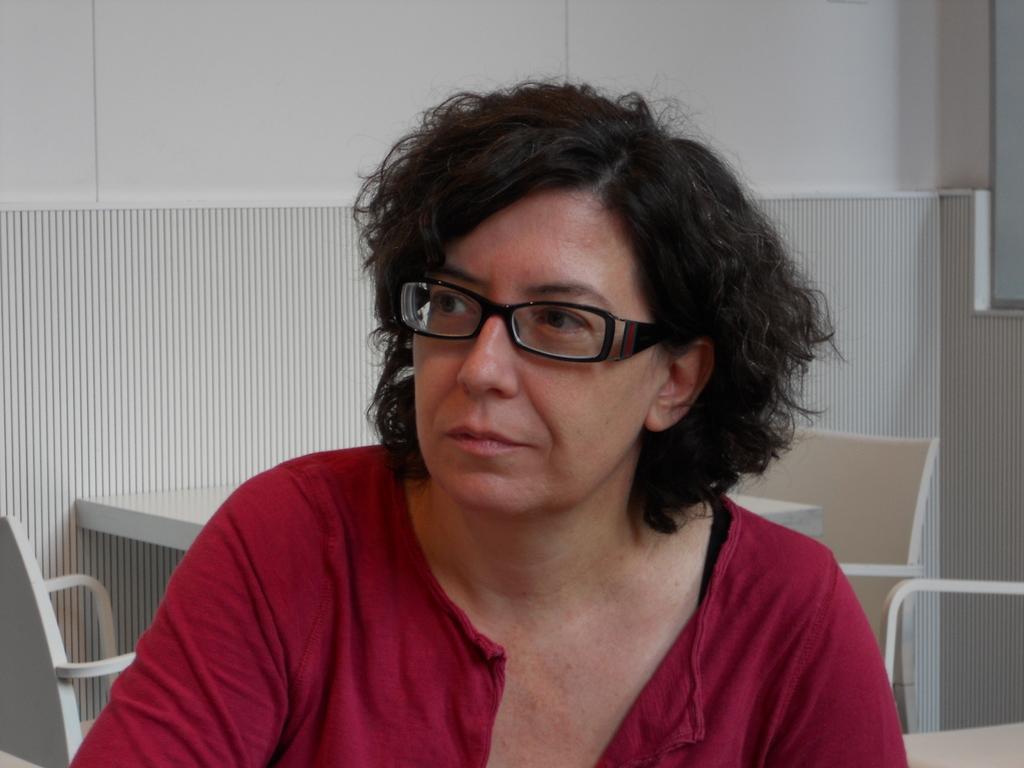Can you describe this image briefly? In this picture we can see a woman, she is wearing a spectacles and in the background we can see a table, chairs, wall. 